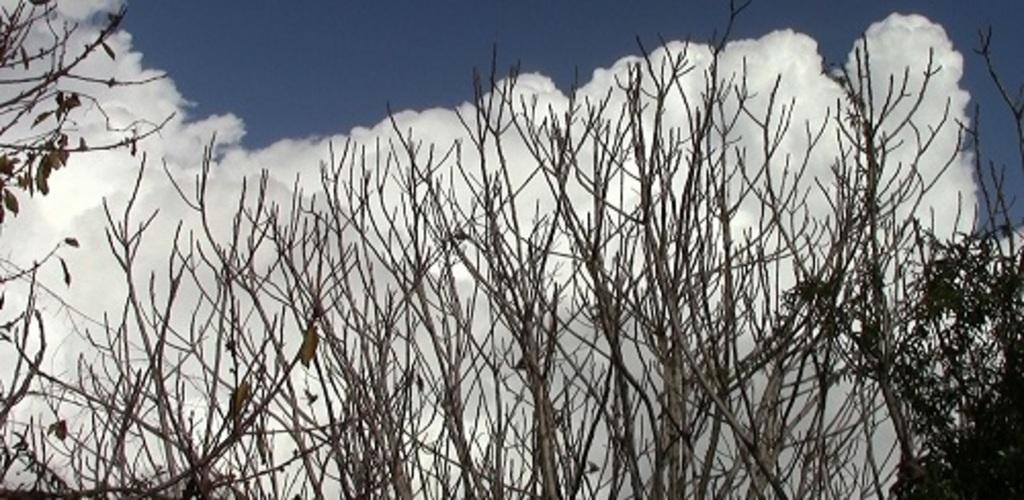What type of vegetation can be seen in the image? There are trees in the image. What part of the natural environment is visible in the image? The sky is visible in the image. What can be observed in the sky? Clouds are present in the sky. Where are the pets being treated in the image? There are no pets or hospital present in the image. 